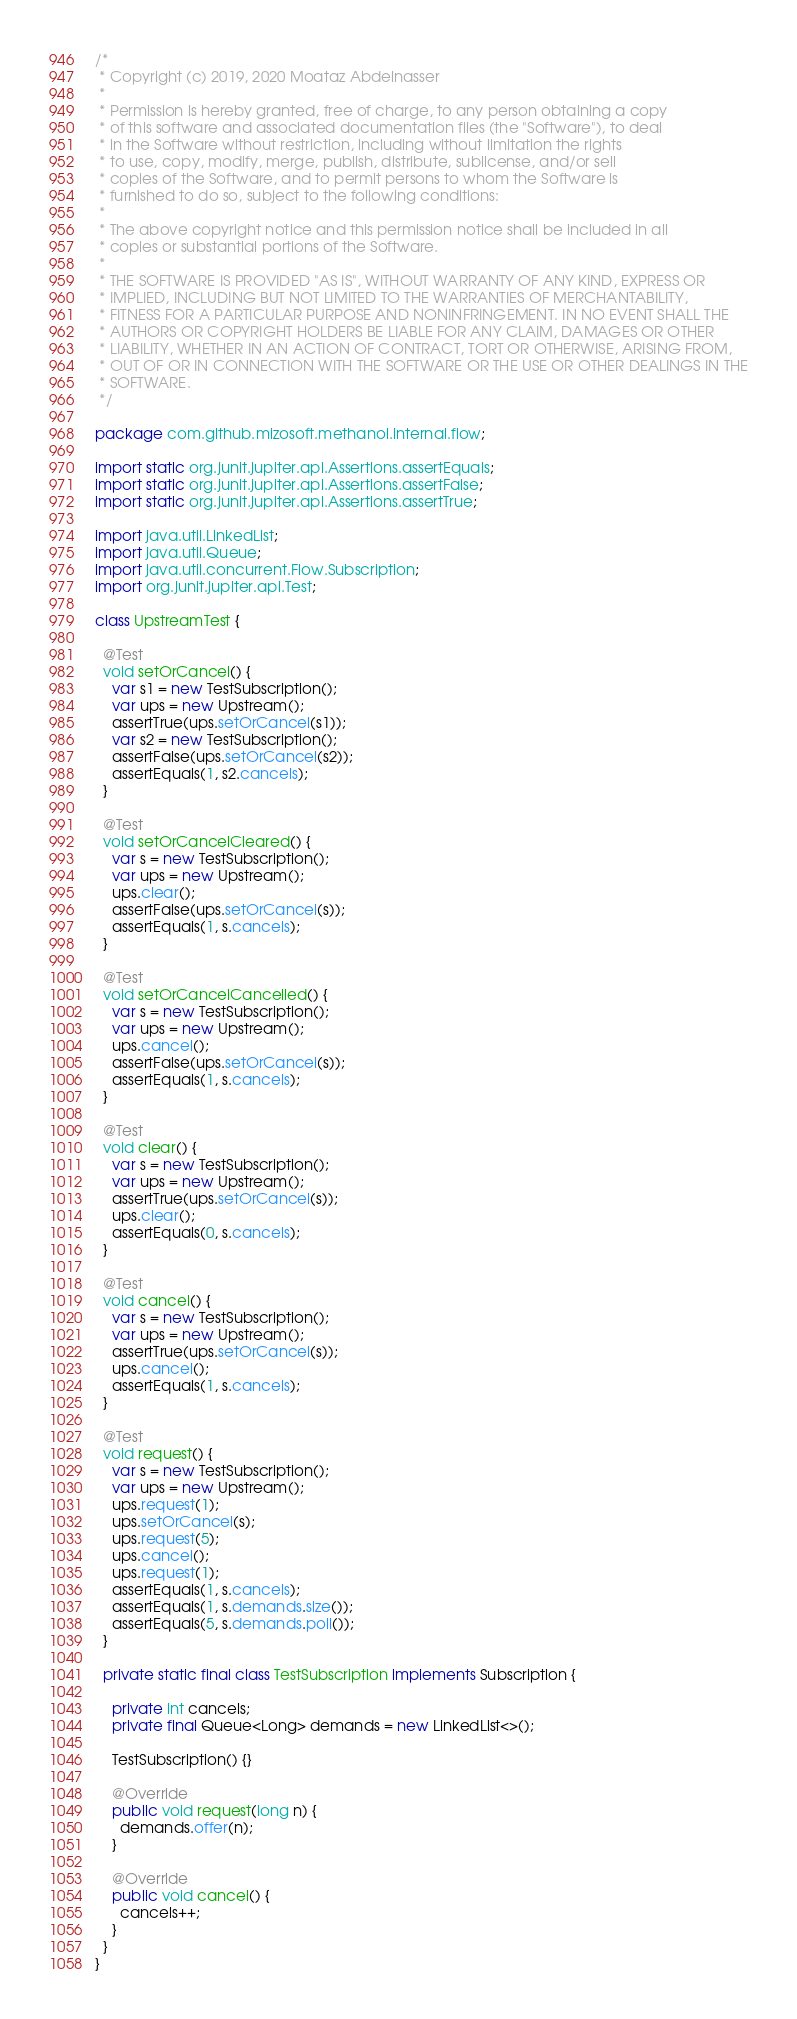<code> <loc_0><loc_0><loc_500><loc_500><_Java_>/*
 * Copyright (c) 2019, 2020 Moataz Abdelnasser
 *
 * Permission is hereby granted, free of charge, to any person obtaining a copy
 * of this software and associated documentation files (the "Software"), to deal
 * in the Software without restriction, including without limitation the rights
 * to use, copy, modify, merge, publish, distribute, sublicense, and/or sell
 * copies of the Software, and to permit persons to whom the Software is
 * furnished to do so, subject to the following conditions:
 *
 * The above copyright notice and this permission notice shall be included in all
 * copies or substantial portions of the Software.
 *
 * THE SOFTWARE IS PROVIDED "AS IS", WITHOUT WARRANTY OF ANY KIND, EXPRESS OR
 * IMPLIED, INCLUDING BUT NOT LIMITED TO THE WARRANTIES OF MERCHANTABILITY,
 * FITNESS FOR A PARTICULAR PURPOSE AND NONINFRINGEMENT. IN NO EVENT SHALL THE
 * AUTHORS OR COPYRIGHT HOLDERS BE LIABLE FOR ANY CLAIM, DAMAGES OR OTHER
 * LIABILITY, WHETHER IN AN ACTION OF CONTRACT, TORT OR OTHERWISE, ARISING FROM,
 * OUT OF OR IN CONNECTION WITH THE SOFTWARE OR THE USE OR OTHER DEALINGS IN THE
 * SOFTWARE.
 */

package com.github.mizosoft.methanol.internal.flow;

import static org.junit.jupiter.api.Assertions.assertEquals;
import static org.junit.jupiter.api.Assertions.assertFalse;
import static org.junit.jupiter.api.Assertions.assertTrue;

import java.util.LinkedList;
import java.util.Queue;
import java.util.concurrent.Flow.Subscription;
import org.junit.jupiter.api.Test;

class UpstreamTest {

  @Test
  void setOrCancel() {
    var s1 = new TestSubscription();
    var ups = new Upstream();
    assertTrue(ups.setOrCancel(s1));
    var s2 = new TestSubscription();
    assertFalse(ups.setOrCancel(s2));
    assertEquals(1, s2.cancels);
  }

  @Test
  void setOrCancelCleared() {
    var s = new TestSubscription();
    var ups = new Upstream();
    ups.clear();
    assertFalse(ups.setOrCancel(s));
    assertEquals(1, s.cancels);
  }

  @Test
  void setOrCancelCancelled() {
    var s = new TestSubscription();
    var ups = new Upstream();
    ups.cancel();
    assertFalse(ups.setOrCancel(s));
    assertEquals(1, s.cancels);
  }

  @Test
  void clear() {
    var s = new TestSubscription();
    var ups = new Upstream();
    assertTrue(ups.setOrCancel(s));
    ups.clear();
    assertEquals(0, s.cancels);
  }

  @Test
  void cancel() {
    var s = new TestSubscription();
    var ups = new Upstream();
    assertTrue(ups.setOrCancel(s));
    ups.cancel();
    assertEquals(1, s.cancels);
  }

  @Test
  void request() {
    var s = new TestSubscription();
    var ups = new Upstream();
    ups.request(1);
    ups.setOrCancel(s);
    ups.request(5);
    ups.cancel();
    ups.request(1);
    assertEquals(1, s.cancels);
    assertEquals(1, s.demands.size());
    assertEquals(5, s.demands.poll());
  }

  private static final class TestSubscription implements Subscription {

    private int cancels;
    private final Queue<Long> demands = new LinkedList<>();

    TestSubscription() {}

    @Override
    public void request(long n) {
      demands.offer(n);
    }

    @Override
    public void cancel() {
      cancels++;
    }
  }
}</code> 